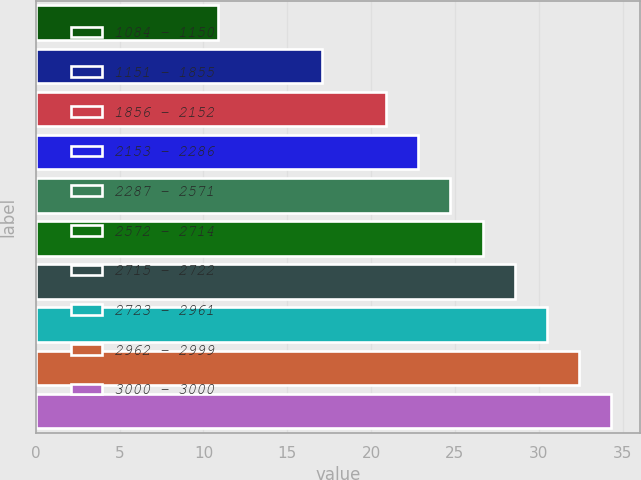Convert chart. <chart><loc_0><loc_0><loc_500><loc_500><bar_chart><fcel>1084 - 1150<fcel>1151 - 1855<fcel>1856 - 2152<fcel>2153 - 2286<fcel>2287 - 2571<fcel>2572 - 2714<fcel>2715 - 2722<fcel>2723 - 2961<fcel>2962 - 2999<fcel>3000 - 3000<nl><fcel>10.84<fcel>17.05<fcel>20.89<fcel>22.81<fcel>24.73<fcel>26.65<fcel>28.57<fcel>30.49<fcel>32.41<fcel>34.33<nl></chart> 